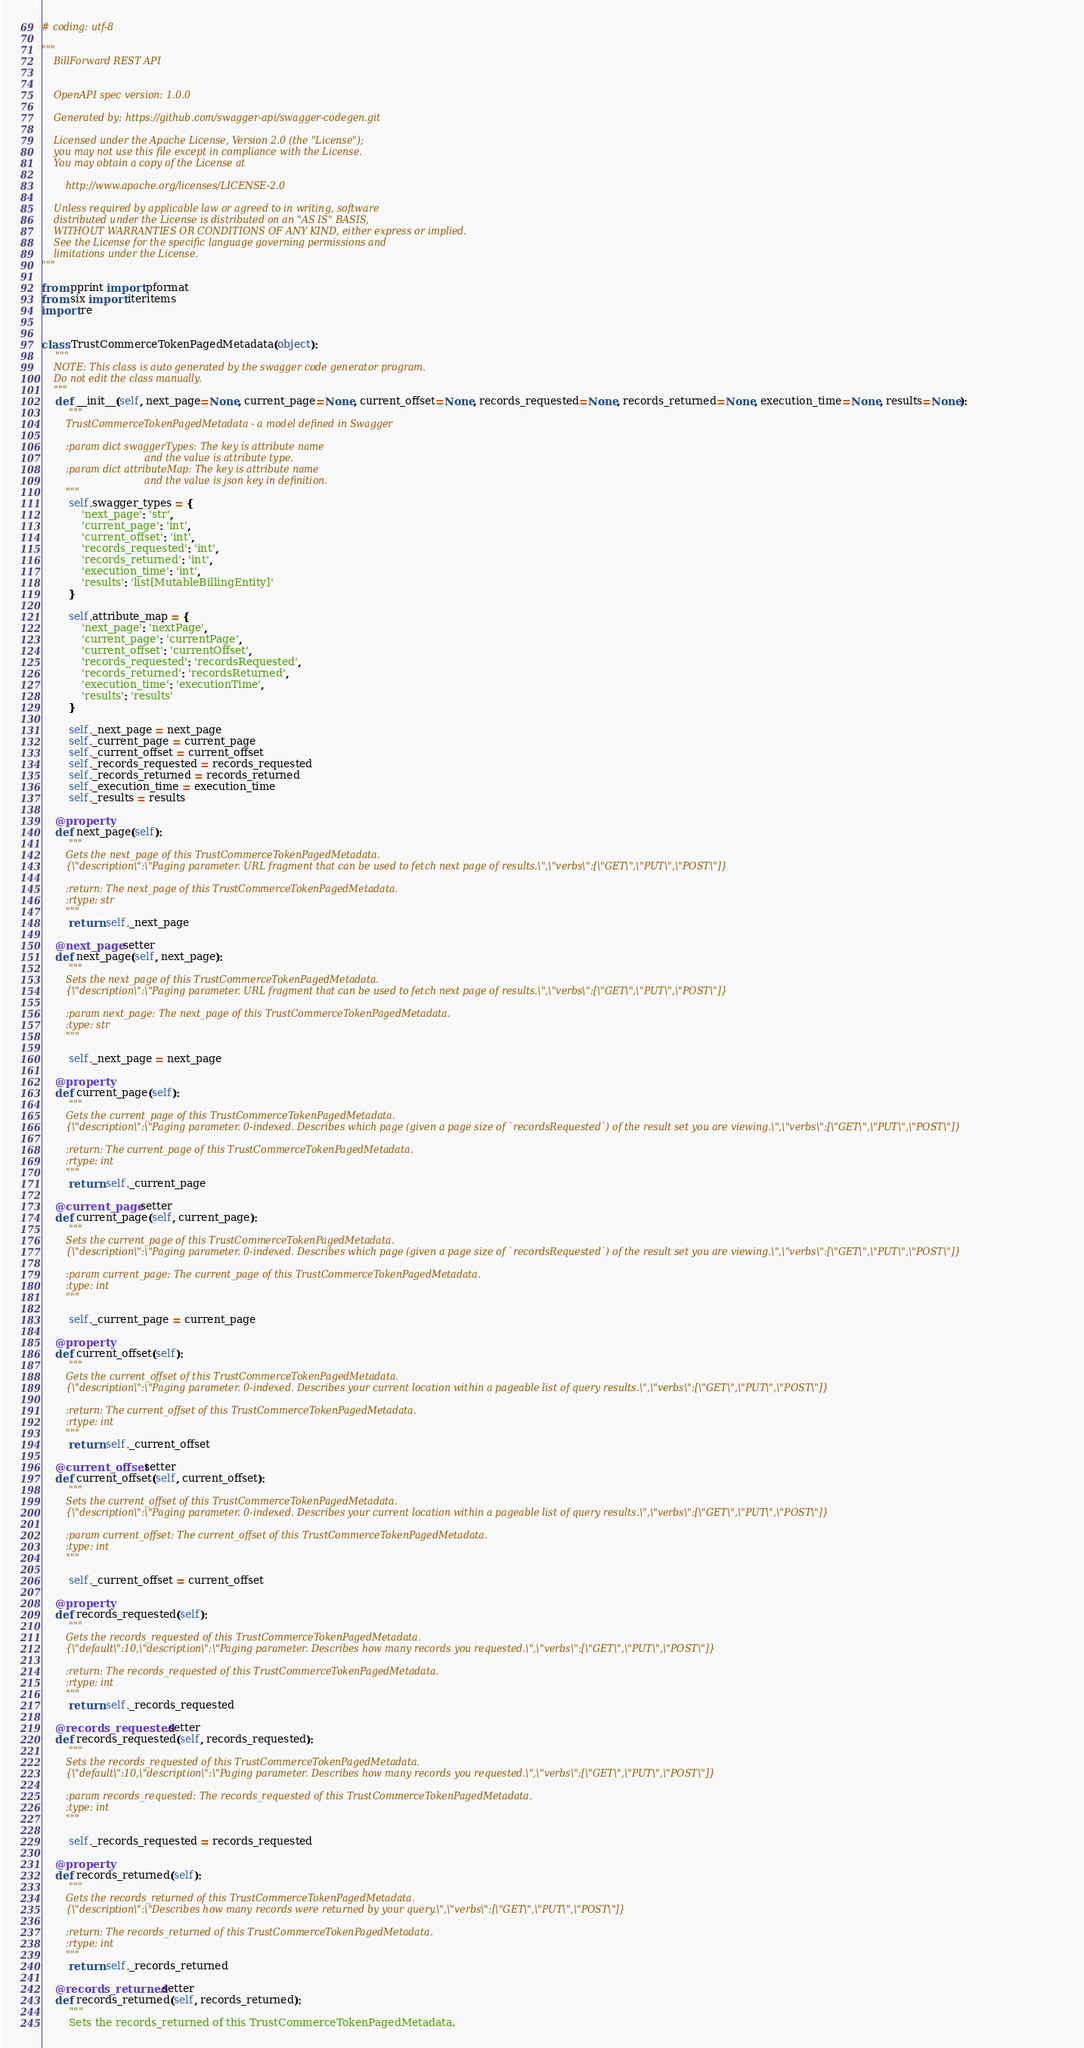<code> <loc_0><loc_0><loc_500><loc_500><_Python_># coding: utf-8

"""
    BillForward REST API


    OpenAPI spec version: 1.0.0
    
    Generated by: https://github.com/swagger-api/swagger-codegen.git

    Licensed under the Apache License, Version 2.0 (the "License");
    you may not use this file except in compliance with the License.
    You may obtain a copy of the License at

        http://www.apache.org/licenses/LICENSE-2.0

    Unless required by applicable law or agreed to in writing, software
    distributed under the License is distributed on an "AS IS" BASIS,
    WITHOUT WARRANTIES OR CONDITIONS OF ANY KIND, either express or implied.
    See the License for the specific language governing permissions and
    limitations under the License.
"""

from pprint import pformat
from six import iteritems
import re


class TrustCommerceTokenPagedMetadata(object):
    """
    NOTE: This class is auto generated by the swagger code generator program.
    Do not edit the class manually.
    """
    def __init__(self, next_page=None, current_page=None, current_offset=None, records_requested=None, records_returned=None, execution_time=None, results=None):
        """
        TrustCommerceTokenPagedMetadata - a model defined in Swagger

        :param dict swaggerTypes: The key is attribute name
                                  and the value is attribute type.
        :param dict attributeMap: The key is attribute name
                                  and the value is json key in definition.
        """
        self.swagger_types = {
            'next_page': 'str',
            'current_page': 'int',
            'current_offset': 'int',
            'records_requested': 'int',
            'records_returned': 'int',
            'execution_time': 'int',
            'results': 'list[MutableBillingEntity]'
        }

        self.attribute_map = {
            'next_page': 'nextPage',
            'current_page': 'currentPage',
            'current_offset': 'currentOffset',
            'records_requested': 'recordsRequested',
            'records_returned': 'recordsReturned',
            'execution_time': 'executionTime',
            'results': 'results'
        }

        self._next_page = next_page
        self._current_page = current_page
        self._current_offset = current_offset
        self._records_requested = records_requested
        self._records_returned = records_returned
        self._execution_time = execution_time
        self._results = results

    @property
    def next_page(self):
        """
        Gets the next_page of this TrustCommerceTokenPagedMetadata.
        {\"description\":\"Paging parameter. URL fragment that can be used to fetch next page of results.\",\"verbs\":[\"GET\",\"PUT\",\"POST\"]}

        :return: The next_page of this TrustCommerceTokenPagedMetadata.
        :rtype: str
        """
        return self._next_page

    @next_page.setter
    def next_page(self, next_page):
        """
        Sets the next_page of this TrustCommerceTokenPagedMetadata.
        {\"description\":\"Paging parameter. URL fragment that can be used to fetch next page of results.\",\"verbs\":[\"GET\",\"PUT\",\"POST\"]}

        :param next_page: The next_page of this TrustCommerceTokenPagedMetadata.
        :type: str
        """

        self._next_page = next_page

    @property
    def current_page(self):
        """
        Gets the current_page of this TrustCommerceTokenPagedMetadata.
        {\"description\":\"Paging parameter. 0-indexed. Describes which page (given a page size of `recordsRequested`) of the result set you are viewing.\",\"verbs\":[\"GET\",\"PUT\",\"POST\"]}

        :return: The current_page of this TrustCommerceTokenPagedMetadata.
        :rtype: int
        """
        return self._current_page

    @current_page.setter
    def current_page(self, current_page):
        """
        Sets the current_page of this TrustCommerceTokenPagedMetadata.
        {\"description\":\"Paging parameter. 0-indexed. Describes which page (given a page size of `recordsRequested`) of the result set you are viewing.\",\"verbs\":[\"GET\",\"PUT\",\"POST\"]}

        :param current_page: The current_page of this TrustCommerceTokenPagedMetadata.
        :type: int
        """

        self._current_page = current_page

    @property
    def current_offset(self):
        """
        Gets the current_offset of this TrustCommerceTokenPagedMetadata.
        {\"description\":\"Paging parameter. 0-indexed. Describes your current location within a pageable list of query results.\",\"verbs\":[\"GET\",\"PUT\",\"POST\"]}

        :return: The current_offset of this TrustCommerceTokenPagedMetadata.
        :rtype: int
        """
        return self._current_offset

    @current_offset.setter
    def current_offset(self, current_offset):
        """
        Sets the current_offset of this TrustCommerceTokenPagedMetadata.
        {\"description\":\"Paging parameter. 0-indexed. Describes your current location within a pageable list of query results.\",\"verbs\":[\"GET\",\"PUT\",\"POST\"]}

        :param current_offset: The current_offset of this TrustCommerceTokenPagedMetadata.
        :type: int
        """

        self._current_offset = current_offset

    @property
    def records_requested(self):
        """
        Gets the records_requested of this TrustCommerceTokenPagedMetadata.
        {\"default\":10,\"description\":\"Paging parameter. Describes how many records you requested.\",\"verbs\":[\"GET\",\"PUT\",\"POST\"]}

        :return: The records_requested of this TrustCommerceTokenPagedMetadata.
        :rtype: int
        """
        return self._records_requested

    @records_requested.setter
    def records_requested(self, records_requested):
        """
        Sets the records_requested of this TrustCommerceTokenPagedMetadata.
        {\"default\":10,\"description\":\"Paging parameter. Describes how many records you requested.\",\"verbs\":[\"GET\",\"PUT\",\"POST\"]}

        :param records_requested: The records_requested of this TrustCommerceTokenPagedMetadata.
        :type: int
        """

        self._records_requested = records_requested

    @property
    def records_returned(self):
        """
        Gets the records_returned of this TrustCommerceTokenPagedMetadata.
        {\"description\":\"Describes how many records were returned by your query.\",\"verbs\":[\"GET\",\"PUT\",\"POST\"]}

        :return: The records_returned of this TrustCommerceTokenPagedMetadata.
        :rtype: int
        """
        return self._records_returned

    @records_returned.setter
    def records_returned(self, records_returned):
        """
        Sets the records_returned of this TrustCommerceTokenPagedMetadata.</code> 